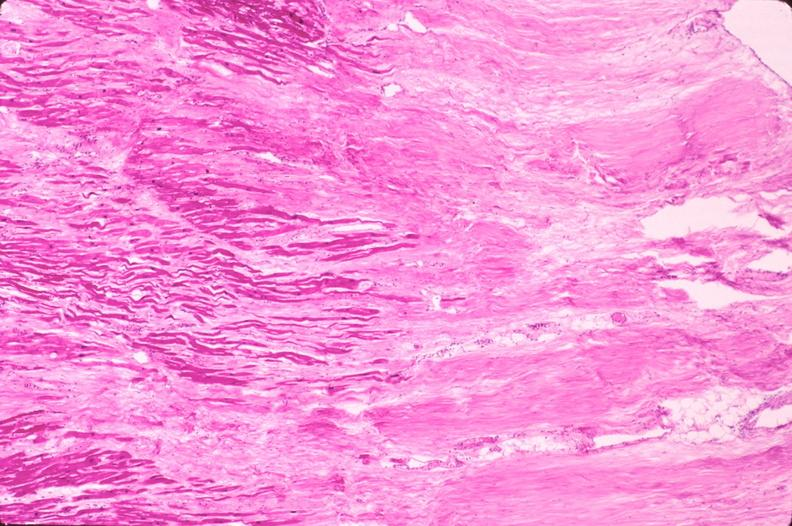s slide present?
Answer the question using a single word or phrase. No 